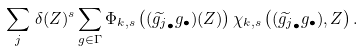Convert formula to latex. <formula><loc_0><loc_0><loc_500><loc_500>\sum _ { j } \, \delta ( Z ) ^ { s } \sum _ { g \in \Gamma } \Phi _ { k , s } \left ( ( \widetilde { g _ { j } } _ { \bullet } g _ { \bullet } ) ( Z ) \right ) \chi _ { k , s } \left ( ( \widetilde { g _ { j } } _ { \bullet } g _ { \bullet } ) , Z \right ) .</formula> 